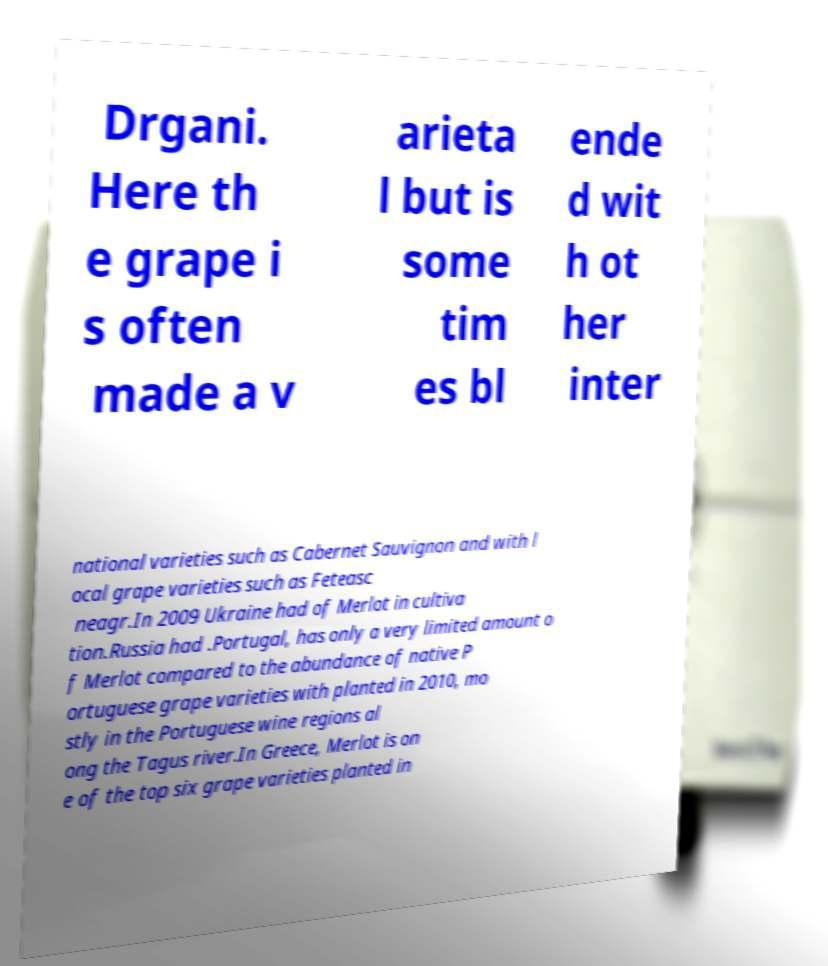What messages or text are displayed in this image? I need them in a readable, typed format. Drgani. Here th e grape i s often made a v arieta l but is some tim es bl ende d wit h ot her inter national varieties such as Cabernet Sauvignon and with l ocal grape varieties such as Feteasc neagr.In 2009 Ukraine had of Merlot in cultiva tion.Russia had .Portugal, has only a very limited amount o f Merlot compared to the abundance of native P ortuguese grape varieties with planted in 2010, mo stly in the Portuguese wine regions al ong the Tagus river.In Greece, Merlot is on e of the top six grape varieties planted in 